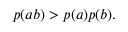Convert formula to latex. <formula><loc_0><loc_0><loc_500><loc_500>\begin{array} { r } { p ( a b ) > p ( a ) p ( b ) . } \end{array}</formula> 